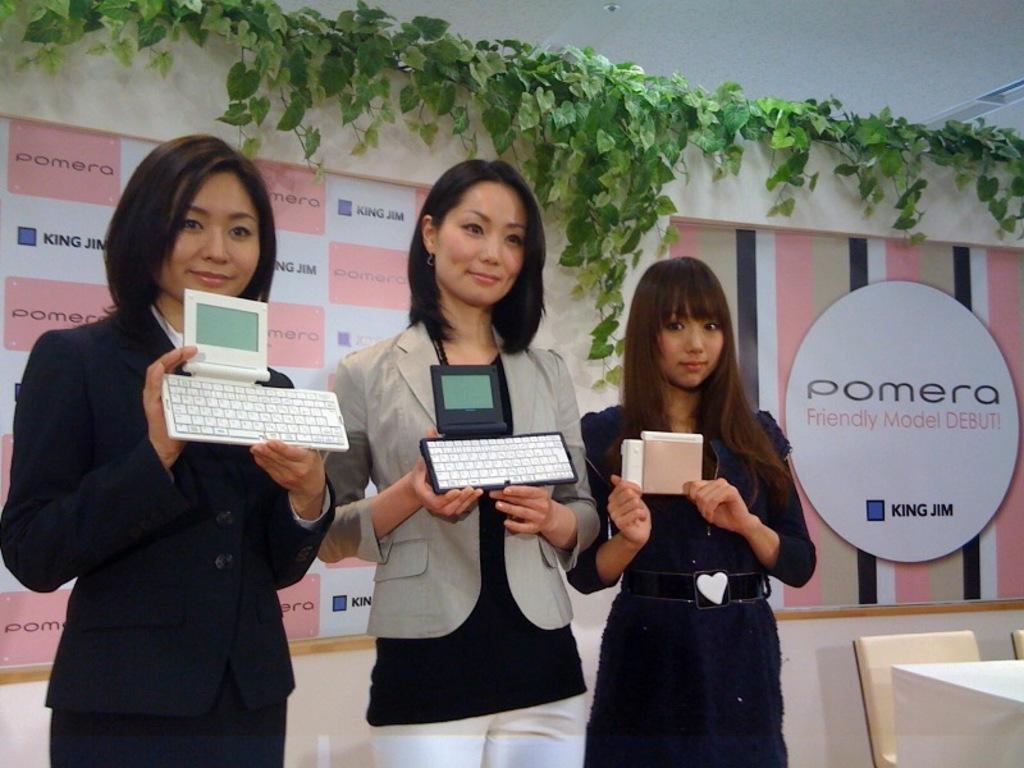Can you describe this image briefly? In this image, we can see three women are standing and electronic instrument in their hand. On the right side corner, we can see table and chair. In the background, we can see hoardings, plants. 